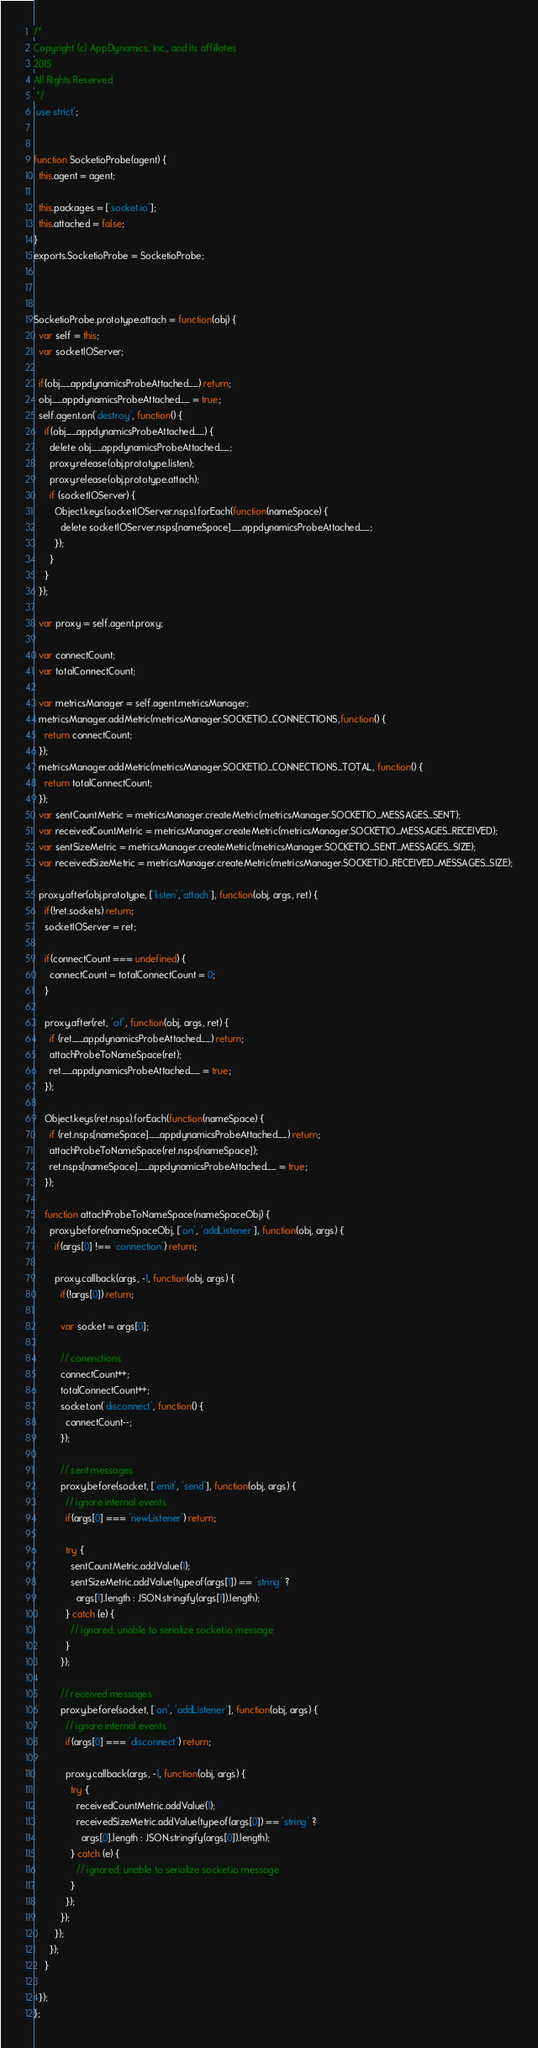<code> <loc_0><loc_0><loc_500><loc_500><_JavaScript_>/*
Copyright (c) AppDynamics, Inc., and its affiliates
2015
All Rights Reserved
 */
'use strict';


function SocketioProbe(agent) {
  this.agent = agent;

  this.packages = ['socket.io'];
  this.attached = false;
}
exports.SocketioProbe = SocketioProbe;



SocketioProbe.prototype.attach = function(obj) {
  var self = this;
  var socketIOServer;

  if(obj.__appdynamicsProbeAttached__) return;
  obj.__appdynamicsProbeAttached__ = true;
  self.agent.on('destroy', function() {
    if(obj.__appdynamicsProbeAttached__) {
      delete obj.__appdynamicsProbeAttached__;
      proxy.release(obj.prototype.listen);
      proxy.release(obj.prototype.attach);
      if (socketIOServer) {
        Object.keys(socketIOServer.nsps).forEach(function(nameSpace) {
          delete socketIOServer.nsps[nameSpace].__appdynamicsProbeAttached__;
        });
      }
    }
  });

  var proxy = self.agent.proxy;

  var connectCount;
  var totalConnectCount;

  var metricsManager = self.agent.metricsManager;
  metricsManager.addMetric(metricsManager.SOCKETIO_CONNECTIONS,function() {
    return connectCount;
  });
  metricsManager.addMetric(metricsManager.SOCKETIO_CONNECTIONS_TOTAL, function() {
    return totalConnectCount;
  });
  var sentCountMetric = metricsManager.createMetric(metricsManager.SOCKETIO_MESSAGES_SENT);
  var receivedCountMetric = metricsManager.createMetric(metricsManager.SOCKETIO_MESSAGES_RECEIVED);
  var sentSizeMetric = metricsManager.createMetric(metricsManager.SOCKETIO_SENT_MESSAGES_SIZE);
  var receivedSizeMetric = metricsManager.createMetric(metricsManager.SOCKETIO_RECEIVED_MESSAGES_SIZE);

  proxy.after(obj.prototype, ['listen','attach'], function(obj, args, ret) {
    if(!ret.sockets) return;
    socketIOServer = ret;

    if(connectCount === undefined) {
      connectCount = totalConnectCount = 0;
    }

    proxy.after(ret, 'of', function(obj, args, ret) {
      if (ret.__appdynamicsProbeAttached__) return;
      attachProbeToNameSpace(ret);
      ret.__appdynamicsProbeAttached__ = true;
    });

    Object.keys(ret.nsps).forEach(function(nameSpace) {
      if (ret.nsps[nameSpace].__appdynamicsProbeAttached__) return;
      attachProbeToNameSpace(ret.nsps[nameSpace]);
      ret.nsps[nameSpace].__appdynamicsProbeAttached__ = true;
    });

    function attachProbeToNameSpace(nameSpaceObj) {
      proxy.before(nameSpaceObj, ['on', 'addListener'], function(obj, args) {
        if(args[0] !== 'connection') return;

        proxy.callback(args, -1, function(obj, args) {
          if(!args[0]) return;

          var socket = args[0];

          // conenctions
          connectCount++;
          totalConnectCount++;
          socket.on('disconnect', function() {
            connectCount--;
          });

          // sent messages
          proxy.before(socket, ['emit', 'send'], function(obj, args) {
            // ignore internal events
            if(args[0] === 'newListener') return;

            try {
              sentCountMetric.addValue(1);
              sentSizeMetric.addValue(typeof(args[1]) == 'string' ?
                args[1].length : JSON.stringify(args[1]).length);
            } catch (e) {
              // ignored; unable to serialize socket.io message
            }
          });

          // received messages
          proxy.before(socket, ['on', 'addListener'], function(obj, args) {
            // ignore internal events
            if(args[0] === 'disconnect') return;

            proxy.callback(args, -1, function(obj, args) {
              try {
                receivedCountMetric.addValue(1);
                receivedSizeMetric.addValue(typeof(args[0]) == 'string' ?
                  args[0].length : JSON.stringify(args[0]).length);
              } catch (e) {
                // ignored; unable to serialize socket.io message
              }
            });
          });
        });
      });
    }

  });
};
</code> 